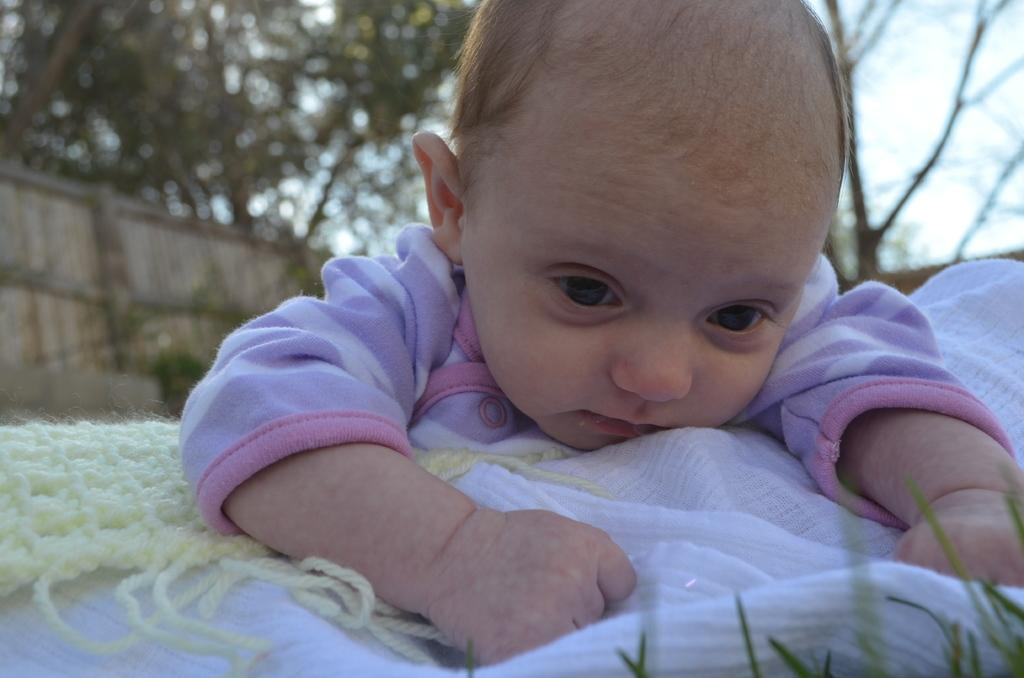What is the main subject of the image? There is a baby in the image. What else can be seen in the image besides the baby? There are clothes and grass visible in the image. What is visible in the background of the image? There is a wall, trees, and the sky visible in the background of the image. How many oranges are hanging from the tree in the image? There are no oranges present in the image; the trees in the background are not fruit-bearing trees. What type of star can be seen in the image? There is no star visible in the image; the sky in the background is clear. 